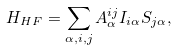Convert formula to latex. <formula><loc_0><loc_0><loc_500><loc_500>H _ { H F } = \sum _ { \alpha , i , j } A ^ { i j } _ { \alpha } I _ { i \alpha } S _ { j \alpha } ,</formula> 